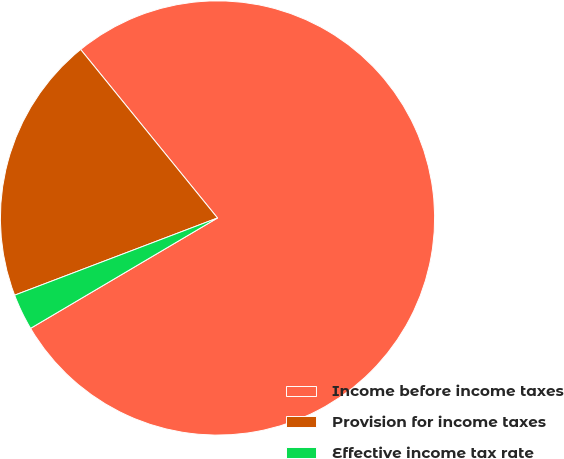Convert chart. <chart><loc_0><loc_0><loc_500><loc_500><pie_chart><fcel>Income before income taxes<fcel>Provision for income taxes<fcel>Effective income tax rate<nl><fcel>77.37%<fcel>19.93%<fcel>2.7%<nl></chart> 